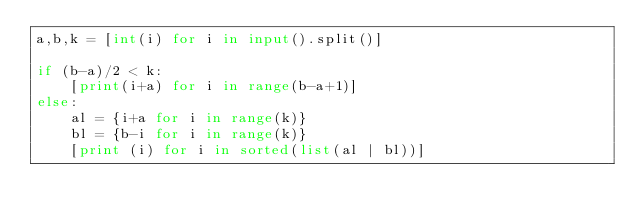<code> <loc_0><loc_0><loc_500><loc_500><_Python_>a,b,k = [int(i) for i in input().split()]

if (b-a)/2 < k:
    [print(i+a) for i in range(b-a+1)]
else:
    al = {i+a for i in range(k)}
    bl = {b-i for i in range(k)}
    [print (i) for i in sorted(list(al | bl))]
        
</code> 